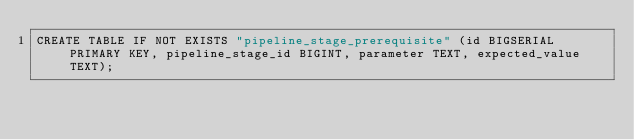Convert code to text. <code><loc_0><loc_0><loc_500><loc_500><_SQL_>CREATE TABLE IF NOT EXISTS "pipeline_stage_prerequisite" (id BIGSERIAL PRIMARY KEY, pipeline_stage_id BIGINT, parameter TEXT, expected_value TEXT);</code> 